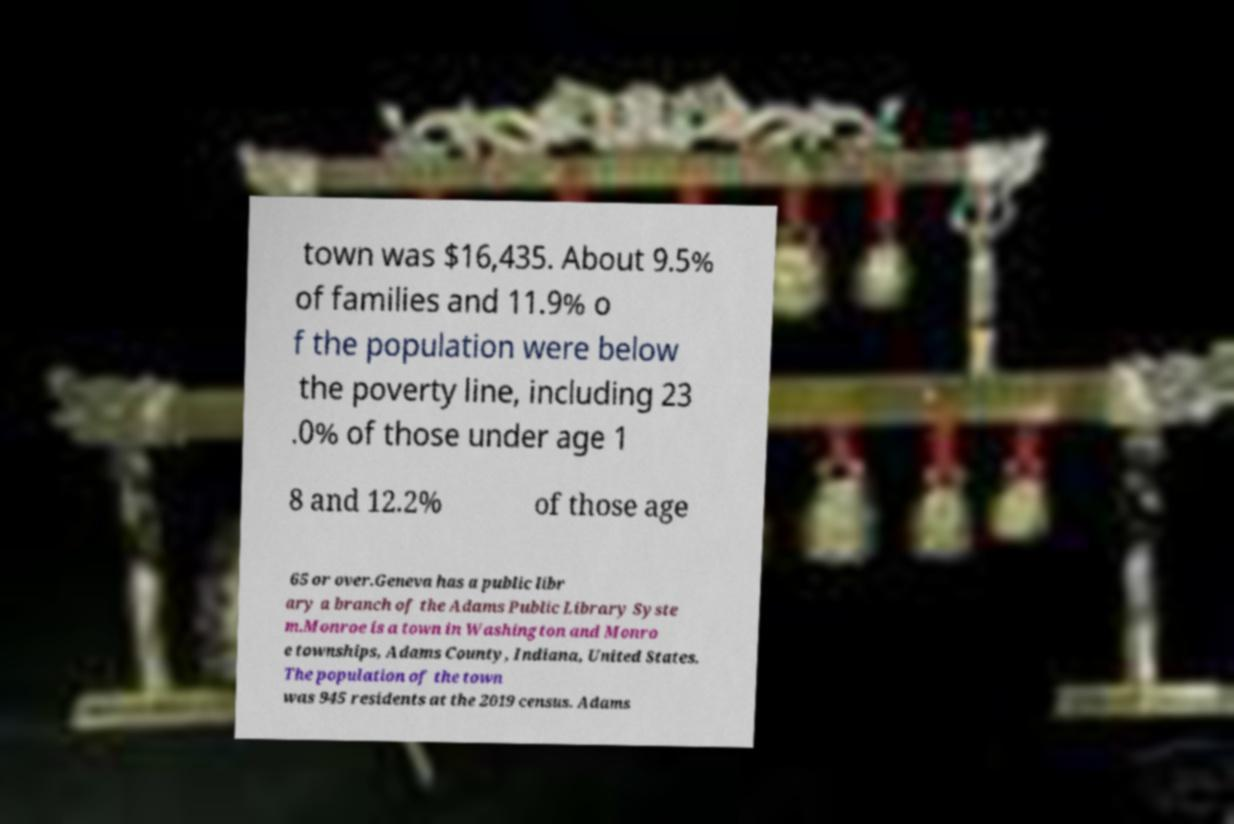There's text embedded in this image that I need extracted. Can you transcribe it verbatim? town was $16,435. About 9.5% of families and 11.9% o f the population were below the poverty line, including 23 .0% of those under age 1 8 and 12.2% of those age 65 or over.Geneva has a public libr ary a branch of the Adams Public Library Syste m.Monroe is a town in Washington and Monro e townships, Adams County, Indiana, United States. The population of the town was 945 residents at the 2019 census. Adams 